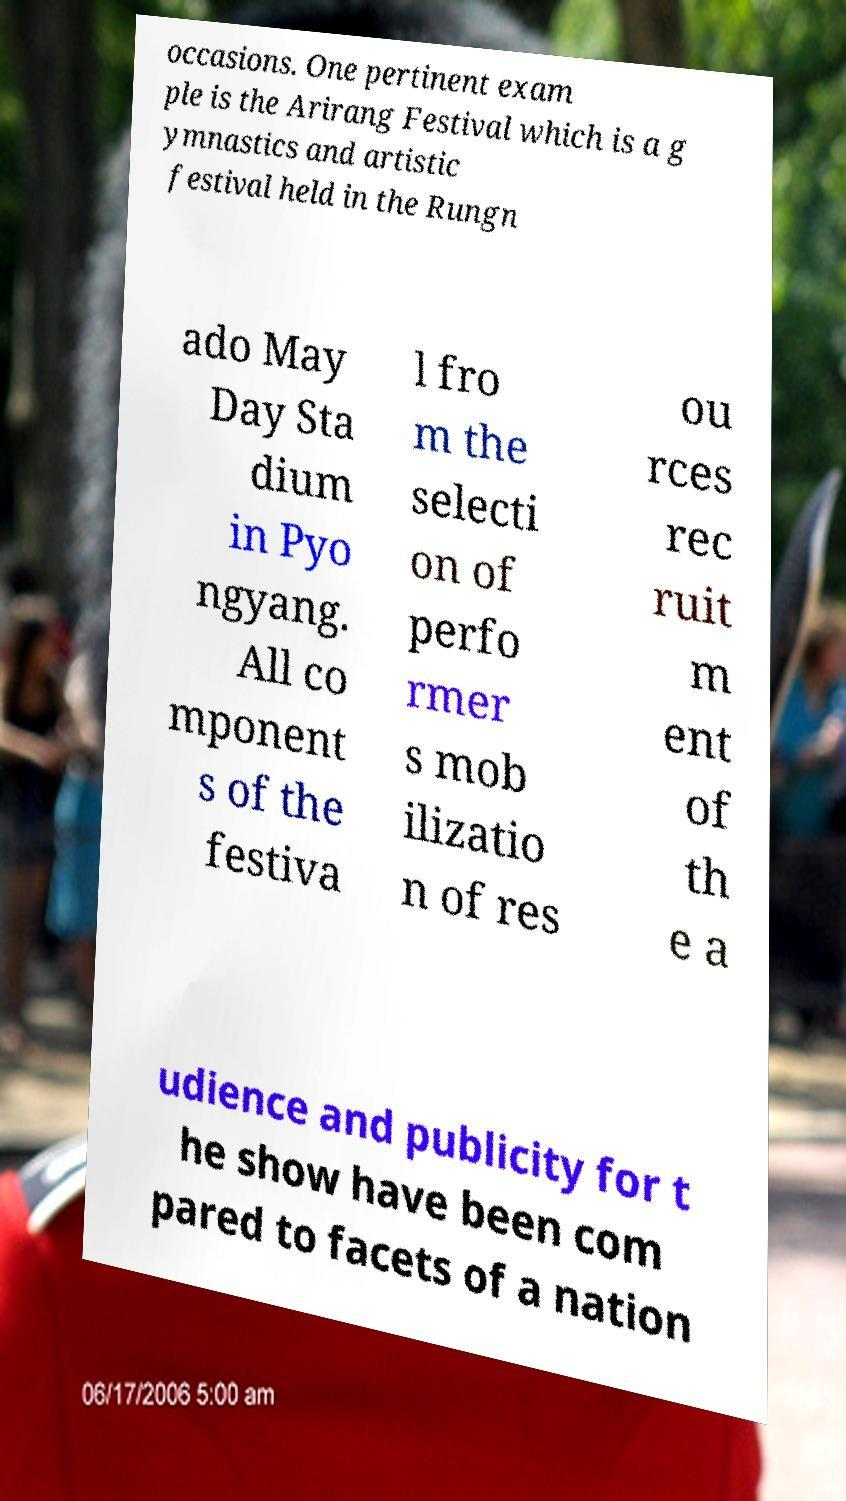For documentation purposes, I need the text within this image transcribed. Could you provide that? occasions. One pertinent exam ple is the Arirang Festival which is a g ymnastics and artistic festival held in the Rungn ado May Day Sta dium in Pyo ngyang. All co mponent s of the festiva l fro m the selecti on of perfo rmer s mob ilizatio n of res ou rces rec ruit m ent of th e a udience and publicity for t he show have been com pared to facets of a nation 